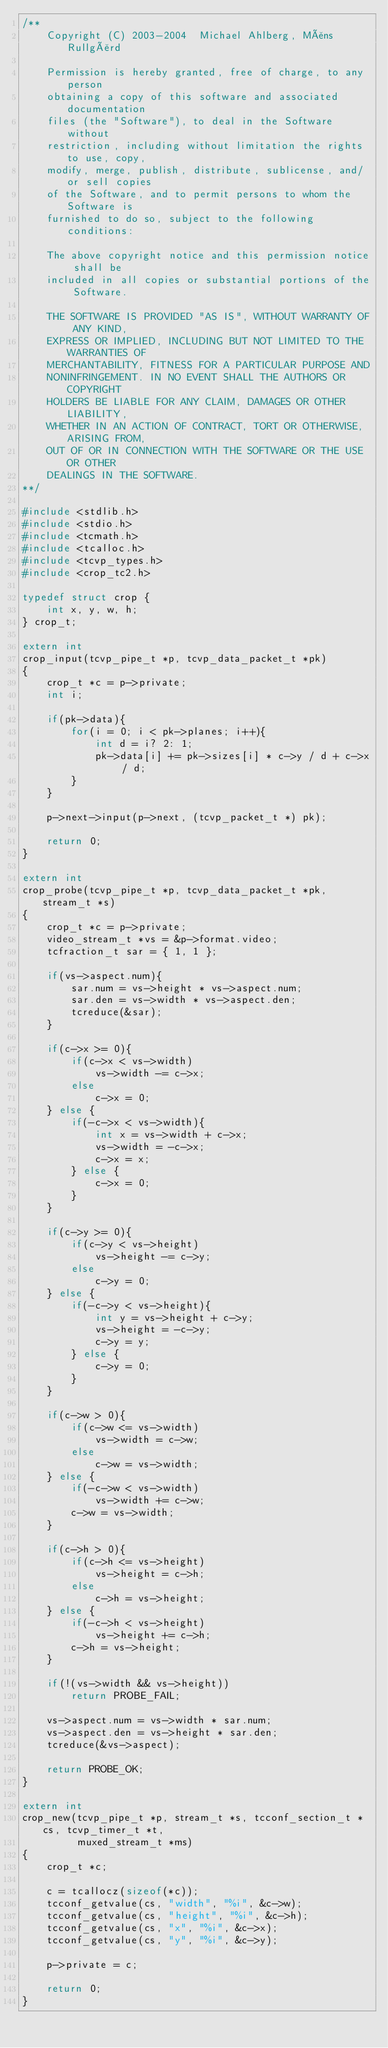<code> <loc_0><loc_0><loc_500><loc_500><_C_>/**
    Copyright (C) 2003-2004  Michael Ahlberg, Måns Rullgård

    Permission is hereby granted, free of charge, to any person
    obtaining a copy of this software and associated documentation
    files (the "Software"), to deal in the Software without
    restriction, including without limitation the rights to use, copy,
    modify, merge, publish, distribute, sublicense, and/or sell copies
    of the Software, and to permit persons to whom the Software is
    furnished to do so, subject to the following conditions:

    The above copyright notice and this permission notice shall be
    included in all copies or substantial portions of the Software.

    THE SOFTWARE IS PROVIDED "AS IS", WITHOUT WARRANTY OF ANY KIND,
    EXPRESS OR IMPLIED, INCLUDING BUT NOT LIMITED TO THE WARRANTIES OF
    MERCHANTABILITY, FITNESS FOR A PARTICULAR PURPOSE AND
    NONINFRINGEMENT. IN NO EVENT SHALL THE AUTHORS OR COPYRIGHT
    HOLDERS BE LIABLE FOR ANY CLAIM, DAMAGES OR OTHER LIABILITY,
    WHETHER IN AN ACTION OF CONTRACT, TORT OR OTHERWISE, ARISING FROM,
    OUT OF OR IN CONNECTION WITH THE SOFTWARE OR THE USE OR OTHER
    DEALINGS IN THE SOFTWARE.
**/

#include <stdlib.h>
#include <stdio.h>
#include <tcmath.h>
#include <tcalloc.h>
#include <tcvp_types.h>
#include <crop_tc2.h>

typedef struct crop {
    int x, y, w, h;
} crop_t;

extern int
crop_input(tcvp_pipe_t *p, tcvp_data_packet_t *pk)
{
    crop_t *c = p->private;
    int i;

    if(pk->data){
        for(i = 0; i < pk->planes; i++){
            int d = i? 2: 1;
            pk->data[i] += pk->sizes[i] * c->y / d + c->x / d;
        }
    }

    p->next->input(p->next, (tcvp_packet_t *) pk);

    return 0;
}

extern int
crop_probe(tcvp_pipe_t *p, tcvp_data_packet_t *pk, stream_t *s)
{
    crop_t *c = p->private;
    video_stream_t *vs = &p->format.video;
    tcfraction_t sar = { 1, 1 };

    if(vs->aspect.num){
        sar.num = vs->height * vs->aspect.num;
        sar.den = vs->width * vs->aspect.den;
        tcreduce(&sar);
    }

    if(c->x >= 0){
        if(c->x < vs->width)
            vs->width -= c->x;
        else
            c->x = 0;
    } else {
        if(-c->x < vs->width){
            int x = vs->width + c->x;
            vs->width = -c->x;
            c->x = x;
        } else {
            c->x = 0;
        }
    }

    if(c->y >= 0){
        if(c->y < vs->height)
            vs->height -= c->y;
        else
            c->y = 0;
    } else {
        if(-c->y < vs->height){
            int y = vs->height + c->y;
            vs->height = -c->y;
            c->y = y;
        } else {
            c->y = 0;
        }
    }

    if(c->w > 0){
        if(c->w <= vs->width)
            vs->width = c->w;
        else
            c->w = vs->width;
    } else {
        if(-c->w < vs->width)
            vs->width += c->w;
        c->w = vs->width;
    }

    if(c->h > 0){
        if(c->h <= vs->height)
            vs->height = c->h;
        else
            c->h = vs->height;
    } else {
        if(-c->h < vs->height)
            vs->height += c->h;
        c->h = vs->height;
    }

    if(!(vs->width && vs->height))
        return PROBE_FAIL;

    vs->aspect.num = vs->width * sar.num;
    vs->aspect.den = vs->height * sar.den;
    tcreduce(&vs->aspect);

    return PROBE_OK;
}

extern int
crop_new(tcvp_pipe_t *p, stream_t *s, tcconf_section_t *cs, tcvp_timer_t *t,
         muxed_stream_t *ms)
{
    crop_t *c;

    c = tcallocz(sizeof(*c));
    tcconf_getvalue(cs, "width", "%i", &c->w);
    tcconf_getvalue(cs, "height", "%i", &c->h);
    tcconf_getvalue(cs, "x", "%i", &c->x);
    tcconf_getvalue(cs, "y", "%i", &c->y);

    p->private = c;

    return 0;
}
</code> 